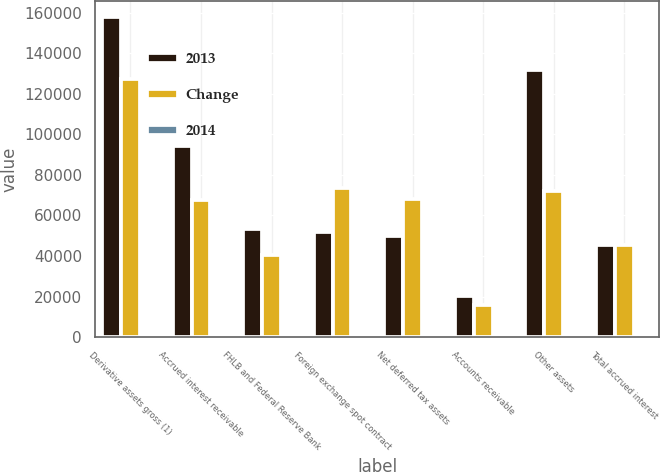Convert chart. <chart><loc_0><loc_0><loc_500><loc_500><stacked_bar_chart><ecel><fcel>Derivative assets gross (1)<fcel>Accrued interest receivable<fcel>FHLB and Federal Reserve Bank<fcel>Foreign exchange spot contract<fcel>Net deferred tax assets<fcel>Accounts receivable<fcel>Other assets<fcel>Total accrued interest<nl><fcel>2013<fcel>157990<fcel>94180<fcel>53496<fcel>51972<fcel>49921<fcel>20092<fcel>131580<fcel>45276.5<nl><fcel>Change<fcel>127114<fcel>67772<fcel>40632<fcel>73423<fcel>68237<fcel>15773<fcel>72159<fcel>45276.5<nl><fcel>2014<fcel>24.3<fcel>39<fcel>31.7<fcel>29.2<fcel>26.8<fcel>27.4<fcel>82.3<fcel>20.2<nl></chart> 